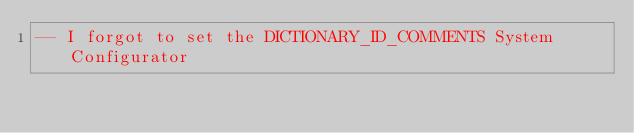<code> <loc_0><loc_0><loc_500><loc_500><_SQL_>-- I forgot to set the DICTIONARY_ID_COMMENTS System Configurator</code> 